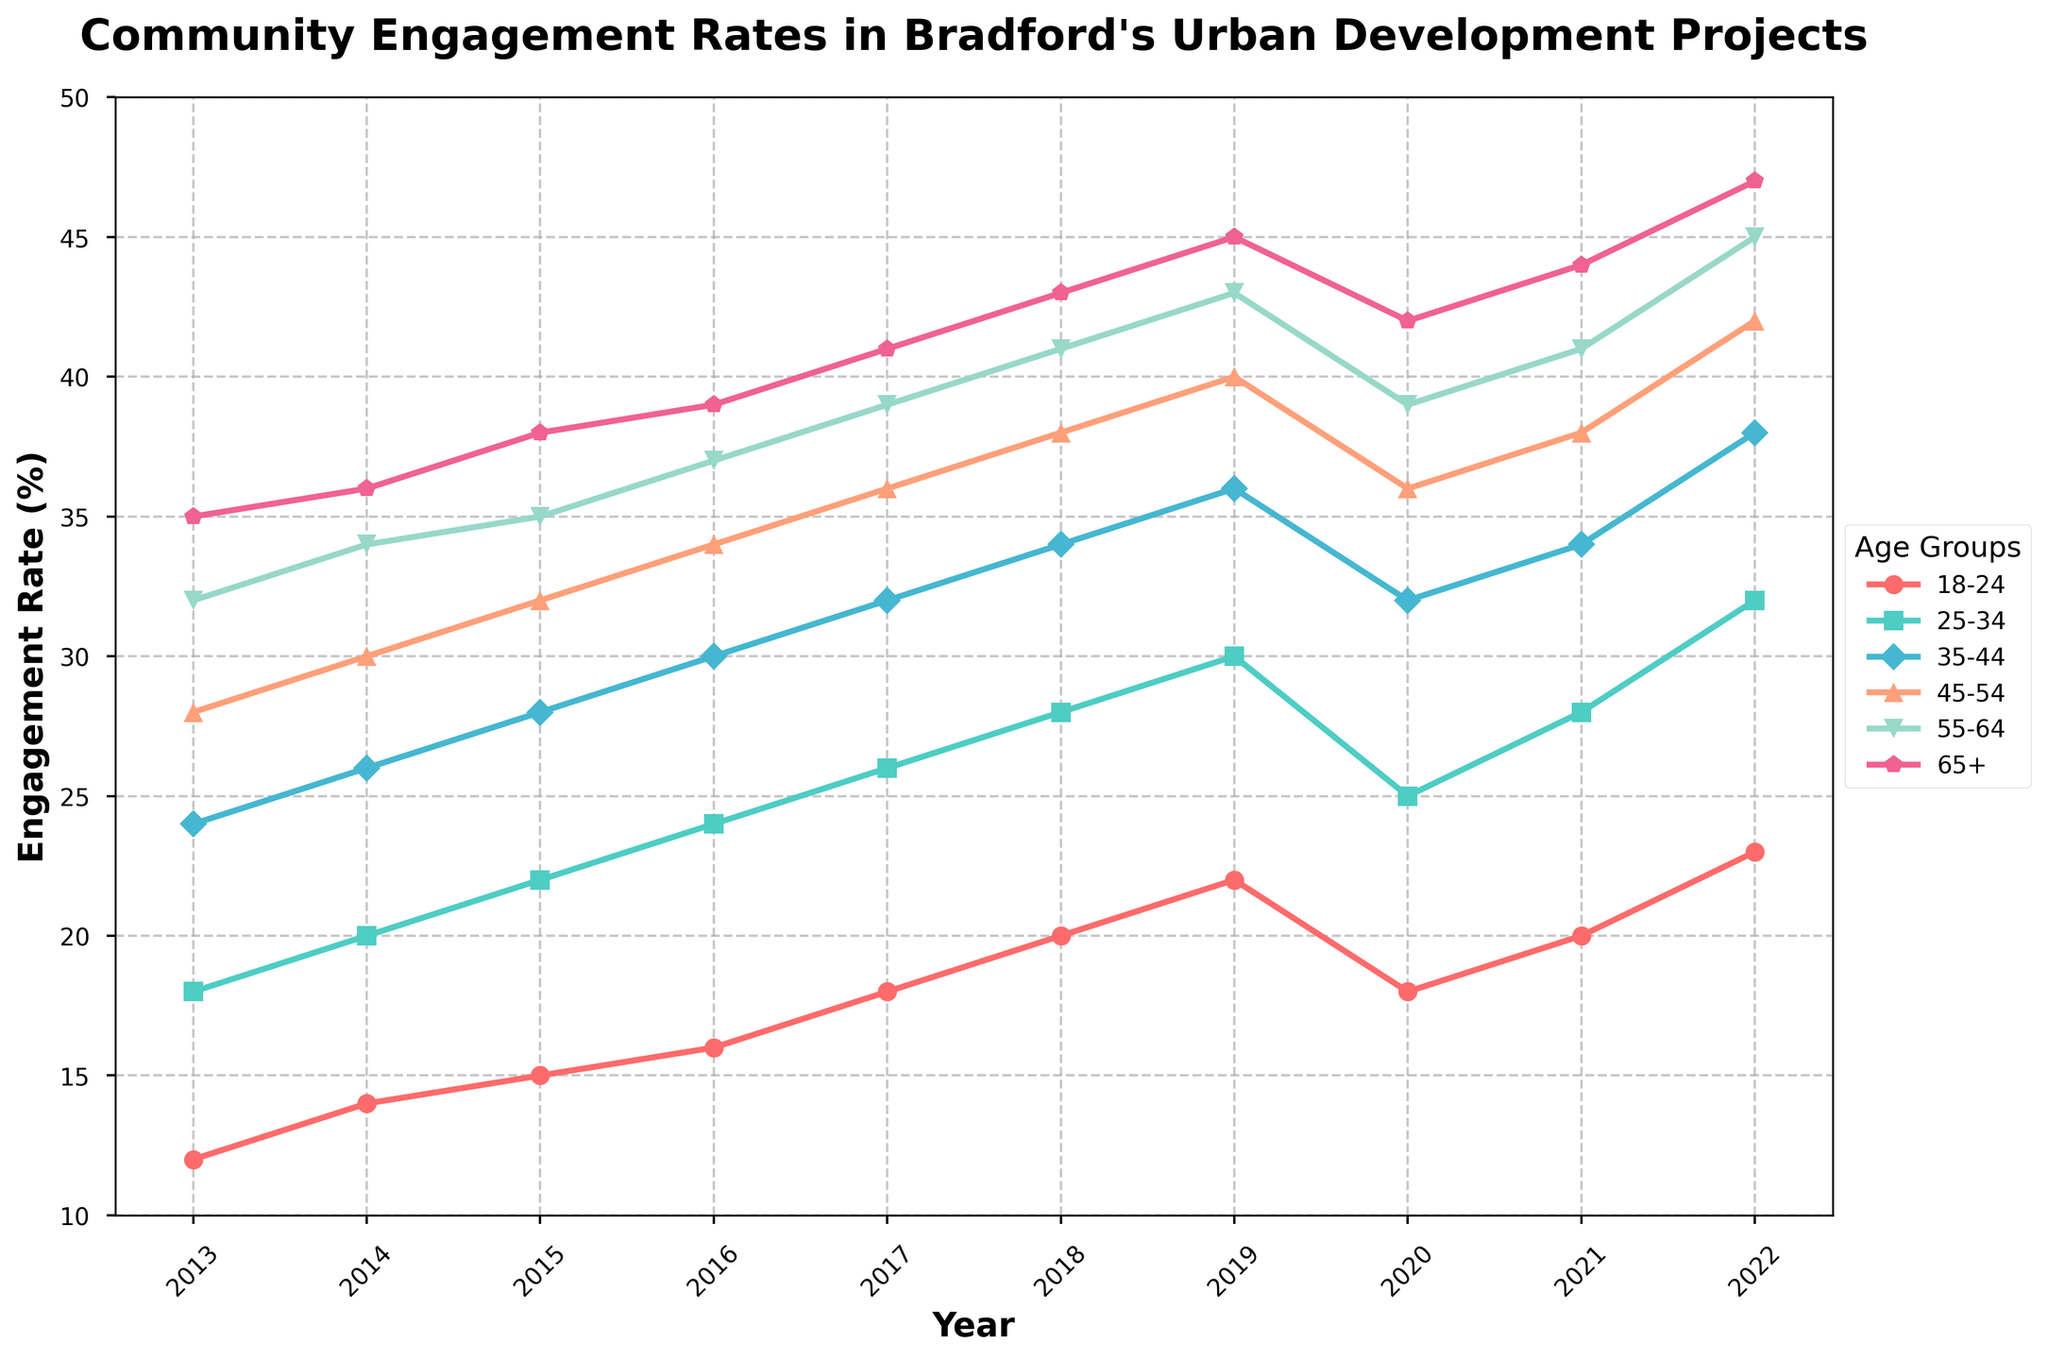Which age group had the highest engagement rate in 2022? To determine which age group had the highest engagement rate in 2022, look at the data points for each age category in the year 2022. The engagement rates for each age group are: 18-24: 23, 25-34: 32, 35-44: 38, 45-54: 42, 55-64: 45, 65+: 47. Among these, the highest value is 47, which corresponds to the 65+ age group.
Answer: 65+ By how much did the engagement rate for the 18-24 age group increase from 2013 to 2022? To find the increase in engagement rate for the 18-24 age group from 2013 to 2022, subtract the 2013 value from the 2022 value. The engagement rate in 2013 was 12, and in 2022 it was 23. The increase is 23 - 12 = 11.
Answer: 11 Which age group showed the most significant overall increase in engagement rates from 2013 to 2022? Calculate the increase in engagement rates for each age group by subtracting the 2013 value from the 2022 value. The increases are: 
- 18-24: 23 - 12 = 11
- 25-34: 32 - 18 = 14
- 35-44: 38 - 24 = 14
- 45-54: 42 - 28 = 14
- 55-64: 45 - 32 = 13
- 65+: 47 - 35 = 12
The most significant increase is 14, which occurred in the 25-34, 35-44, and 45-54 age groups.
Answer: 25-34, 35-44, 45-54 What was the average engagement rate for the 45-54 age group throughout the decade? To calculate the average engagement rate for the 45-54 age group, sum all annual engagement rates and divide by the number of years:
(28 + 30 + 32 + 34 + 36 + 38 + 40 + 36 + 38 + 42) / 10 = 354 / 10 = 35.4.
Answer: 35.4 Did the engagement rate for any age group decrease in 2020 compared to 2019? Compare the engagement rates for all age groups in 2019 and 2020:
- 18-24: 2019: 22, 2020: 18 (decrease)
- 25-34: 2019: 30, 2020: 25 (decrease)
- 35-44: 2019: 36, 2020: 32 (decrease)
- 45-54: 2019: 40, 2020: 36 (decrease)
- 55-64: 2019: 43, 2020: 39 (decrease)
- 65+: 2019: 45, 2020: 42 (decrease)
All groups experienced a decrease in engagement rate in 2020 compared to 2019.
Answer: Yes What is the total sum of engagement rate increases for all age groups from 2013 to 2022? Calculate the increase for each age group and then sum these increases:
- 18-24: 23 - 12 = 11
- 25-34: 32 - 18 = 14
- 35-44: 38 - 24 = 14
- 45-54: 42 - 28 = 14
- 55-64: 45 - 32 = 13
- 65+: 47 - 35 = 12
The total sum is 11 + 14 + 14 + 14 + 13 + 12 = 78.
Answer: 78 How many age groups had an engagement rate of 30 or higher in 2015? Check the engagement rates for all age groups in the year 2015 and count how many are 30 or higher:
- 18-24: 15
- 25-34: 22
- 35-44: 28
- 45-54: 32 (≥ 30)
- 55-64: 35 (≥ 30)
- 65+: 38 (≥ 30)
Three age groups had an engagement rate of 30 or higher.
Answer: 3 